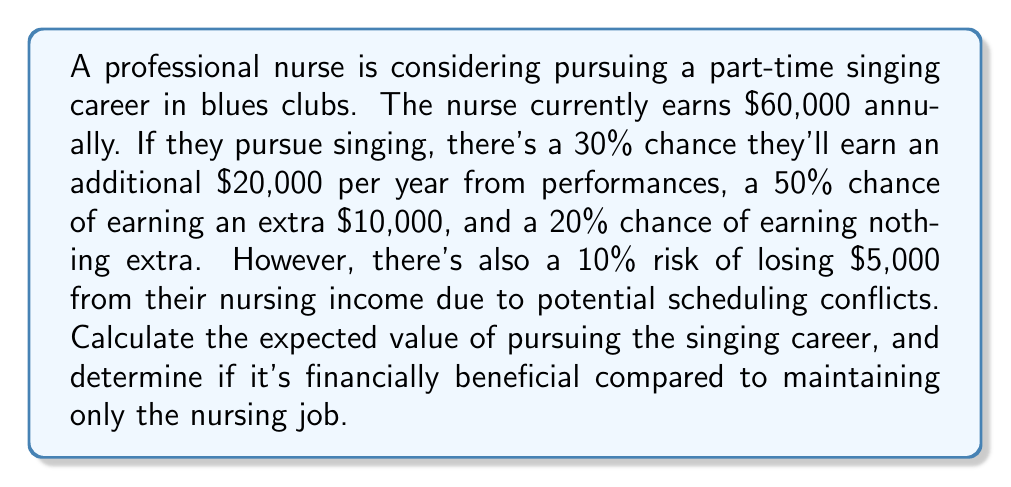Can you answer this question? To solve this problem, we need to calculate the expected value of pursuing the singing career and compare it to the current nursing income. Let's break it down step-by-step:

1. Calculate the expected value of the additional singing income:
   $$E(\text{singing}) = 0.3 \times \$20,000 + 0.5 \times \$10,000 + 0.2 \times \$0 = \$11,000$$

2. Calculate the expected value of the potential loss in nursing income:
   $$E(\text{loss}) = 0.1 \times \$5,000 = \$500$$

3. The total expected value of pursuing the singing career is the sum of the current nursing income, the expected singing income, and the expected loss:
   $$E(\text{total}) = \$60,000 + \$11,000 - \$500 = \$70,500$$

4. Compare the expected value of pursuing both careers to the current nursing income:
   $$\text{Difference} = \$70,500 - \$60,000 = \$10,500$$

The positive difference indicates that pursuing the singing career is financially beneficial.
Answer: The expected value of pursuing the singing career while maintaining the nursing job is $70,500, which is $10,500 more than the current nursing income alone. Therefore, it is financially beneficial to pursue the part-time singing career. 